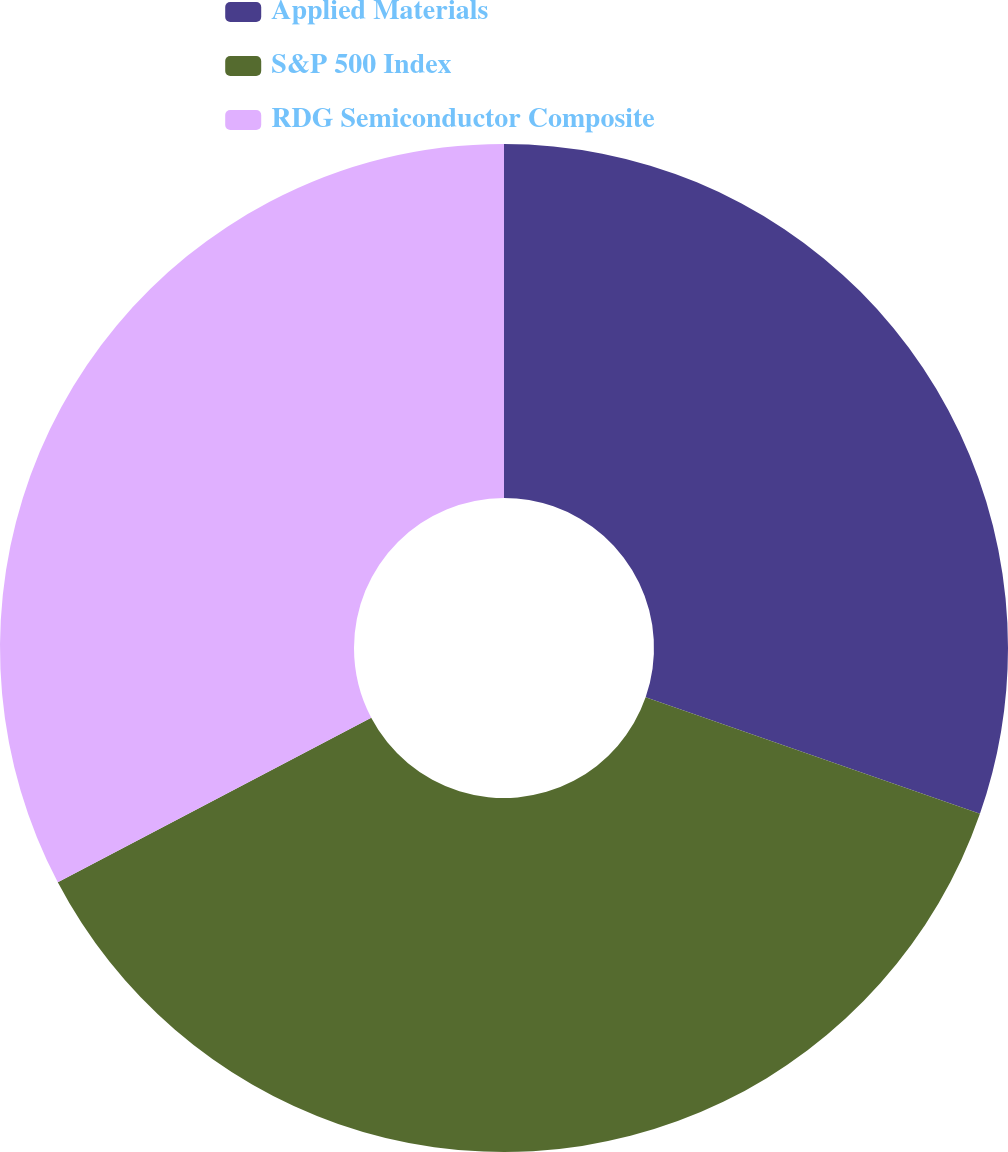Convert chart. <chart><loc_0><loc_0><loc_500><loc_500><pie_chart><fcel>Applied Materials<fcel>S&P 500 Index<fcel>RDG Semiconductor Composite<nl><fcel>30.34%<fcel>36.97%<fcel>32.7%<nl></chart> 